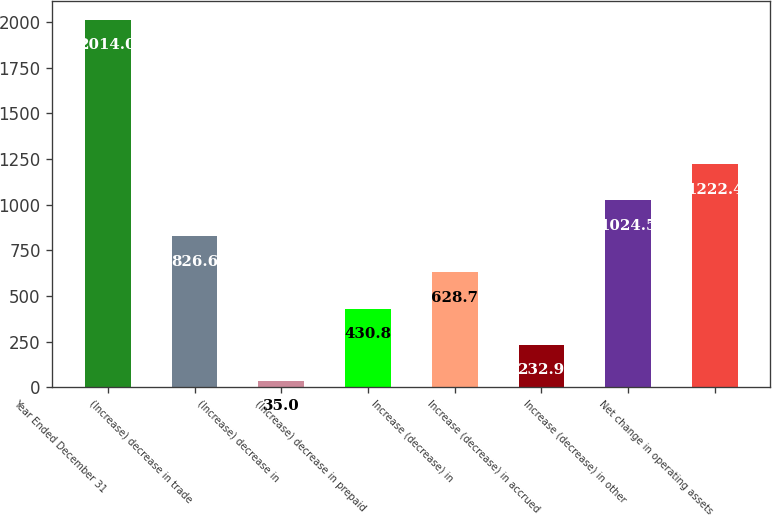Convert chart. <chart><loc_0><loc_0><loc_500><loc_500><bar_chart><fcel>Year Ended December 31<fcel>(Increase) decrease in trade<fcel>(Increase) decrease in<fcel>(Increase) decrease in prepaid<fcel>Increase (decrease) in<fcel>Increase (decrease) in accrued<fcel>Increase (decrease) in other<fcel>Net change in operating assets<nl><fcel>2014<fcel>826.6<fcel>35<fcel>430.8<fcel>628.7<fcel>232.9<fcel>1024.5<fcel>1222.4<nl></chart> 